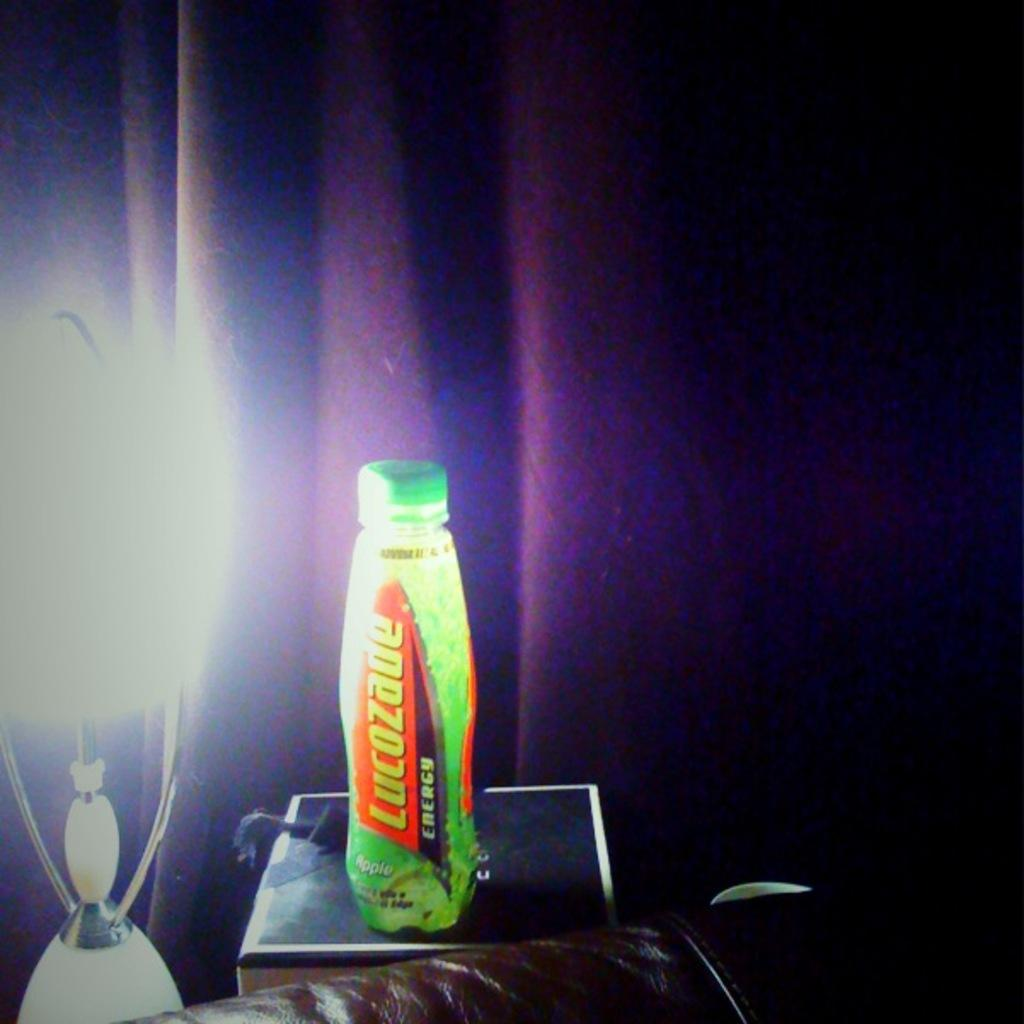<image>
Write a terse but informative summary of the picture. A bottle of Lucozade is on a surface in front of a purple curtain. 